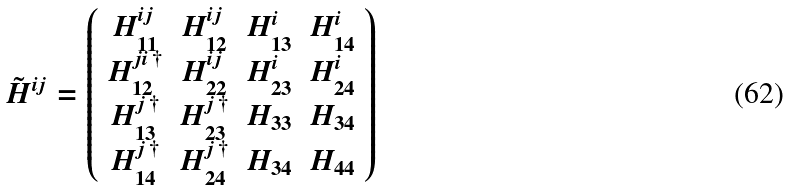<formula> <loc_0><loc_0><loc_500><loc_500>\tilde { H } ^ { i j } = \left ( \begin{array} { c c c c } H _ { 1 1 } ^ { i j } & H _ { 1 2 } ^ { i j } & H _ { 1 3 } ^ { i } & H _ { 1 4 } ^ { i } \\ H _ { 1 2 } ^ { j i \, \dag } & H _ { 2 2 } ^ { i j } & H _ { 2 3 } ^ { i } & H _ { 2 4 } ^ { i } \\ H _ { 1 3 } ^ { j \, \dag } & H _ { 2 3 } ^ { j \, \dag } & H _ { 3 3 } & H _ { 3 4 } \\ H _ { 1 4 } ^ { j \, \dag } & H _ { 2 4 } ^ { j \, \dag } & H _ { 3 4 } & H _ { 4 4 } \end{array} \right )</formula> 